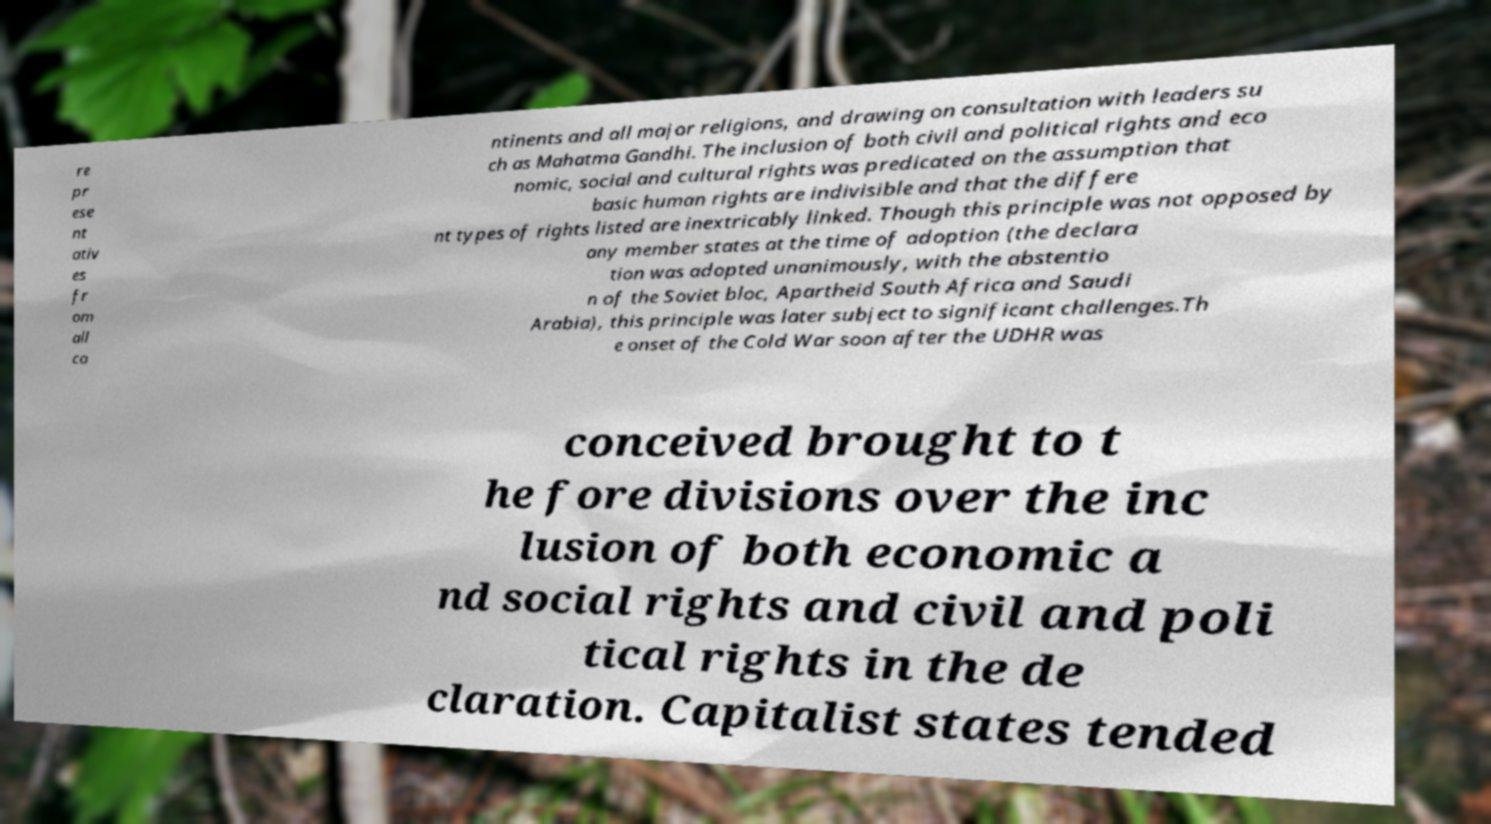Could you extract and type out the text from this image? re pr ese nt ativ es fr om all co ntinents and all major religions, and drawing on consultation with leaders su ch as Mahatma Gandhi. The inclusion of both civil and political rights and eco nomic, social and cultural rights was predicated on the assumption that basic human rights are indivisible and that the differe nt types of rights listed are inextricably linked. Though this principle was not opposed by any member states at the time of adoption (the declara tion was adopted unanimously, with the abstentio n of the Soviet bloc, Apartheid South Africa and Saudi Arabia), this principle was later subject to significant challenges.Th e onset of the Cold War soon after the UDHR was conceived brought to t he fore divisions over the inc lusion of both economic a nd social rights and civil and poli tical rights in the de claration. Capitalist states tended 